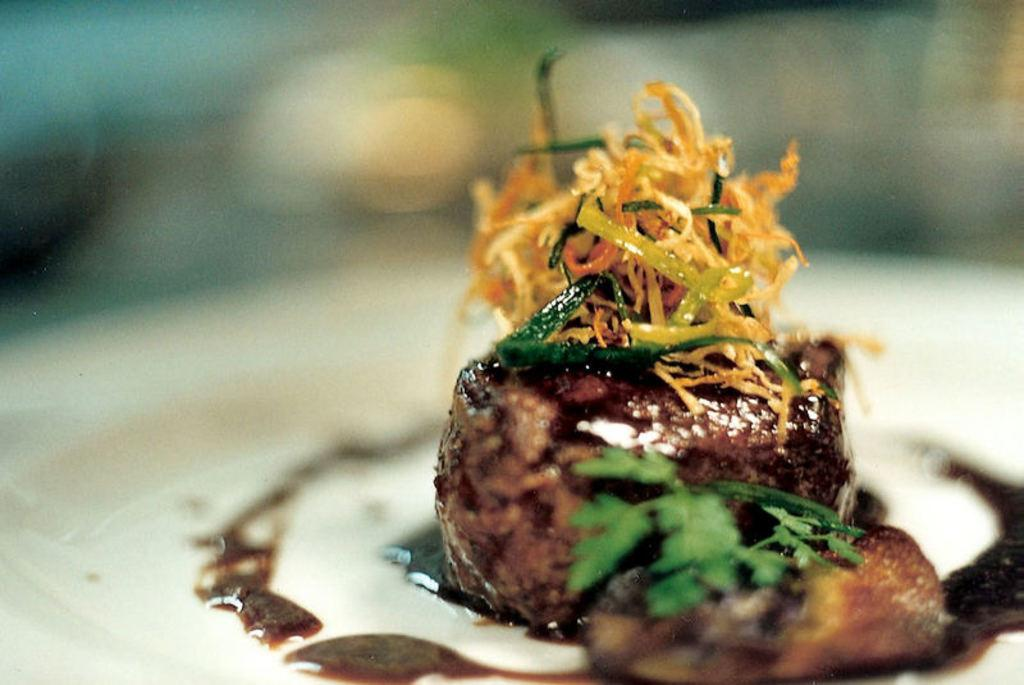What is on the plate in the image? There is food on a plate in the image. Can you describe the background of the image? The background of the image is blurry. What type of love can be seen between the food and the plate in the image? There is no indication of love between the food and the plate in the image, as it is a photograph of a plate with food on it. 